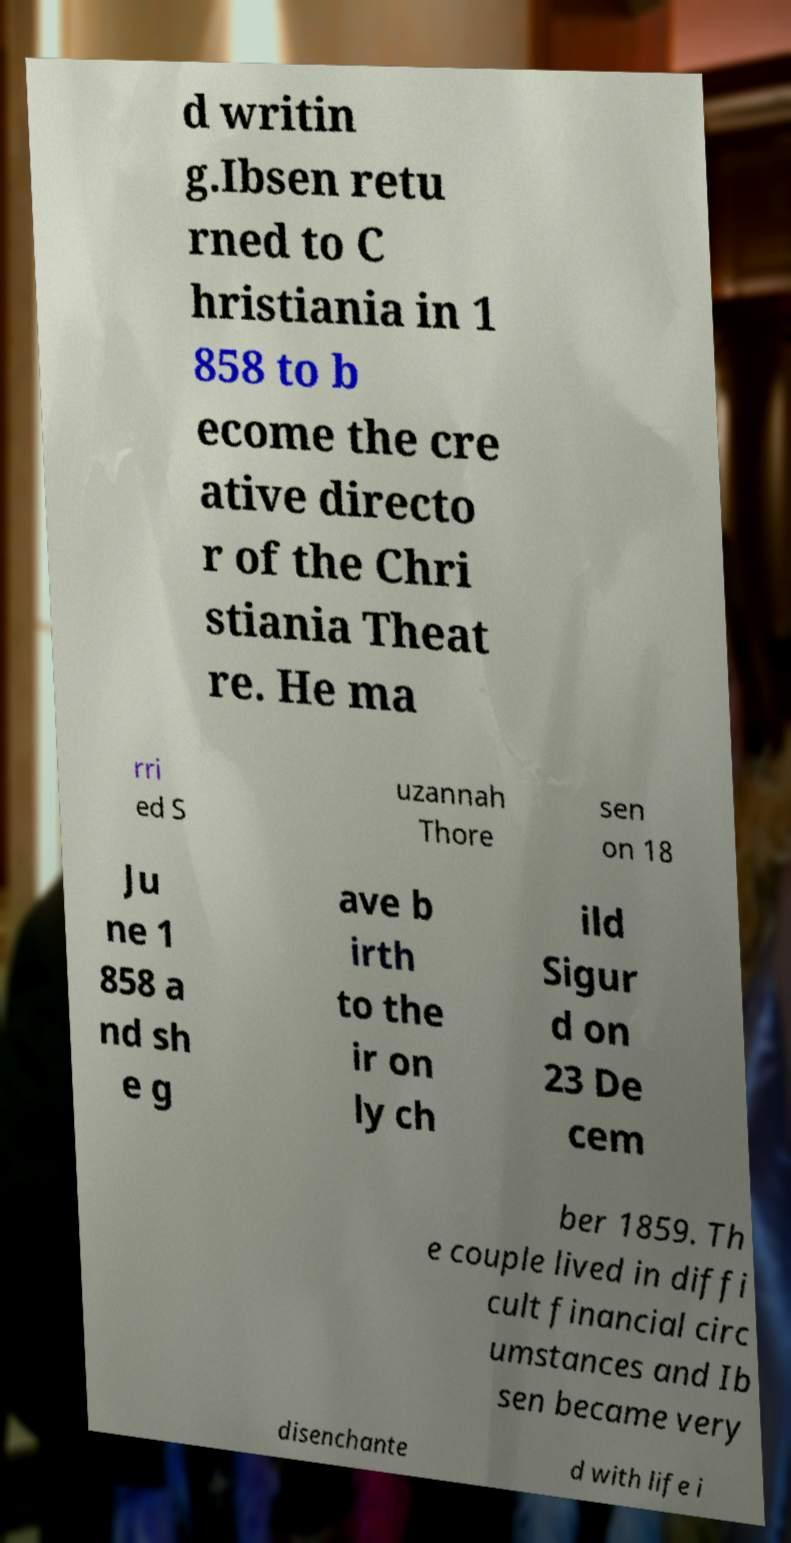Can you read and provide the text displayed in the image?This photo seems to have some interesting text. Can you extract and type it out for me? d writin g.Ibsen retu rned to C hristiania in 1 858 to b ecome the cre ative directo r of the Chri stiania Theat re. He ma rri ed S uzannah Thore sen on 18 Ju ne 1 858 a nd sh e g ave b irth to the ir on ly ch ild Sigur d on 23 De cem ber 1859. Th e couple lived in diffi cult financial circ umstances and Ib sen became very disenchante d with life i 